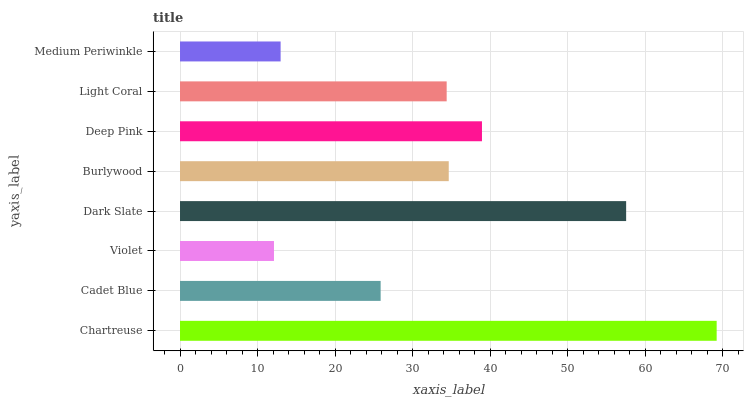Is Violet the minimum?
Answer yes or no. Yes. Is Chartreuse the maximum?
Answer yes or no. Yes. Is Cadet Blue the minimum?
Answer yes or no. No. Is Cadet Blue the maximum?
Answer yes or no. No. Is Chartreuse greater than Cadet Blue?
Answer yes or no. Yes. Is Cadet Blue less than Chartreuse?
Answer yes or no. Yes. Is Cadet Blue greater than Chartreuse?
Answer yes or no. No. Is Chartreuse less than Cadet Blue?
Answer yes or no. No. Is Burlywood the high median?
Answer yes or no. Yes. Is Light Coral the low median?
Answer yes or no. Yes. Is Chartreuse the high median?
Answer yes or no. No. Is Dark Slate the low median?
Answer yes or no. No. 